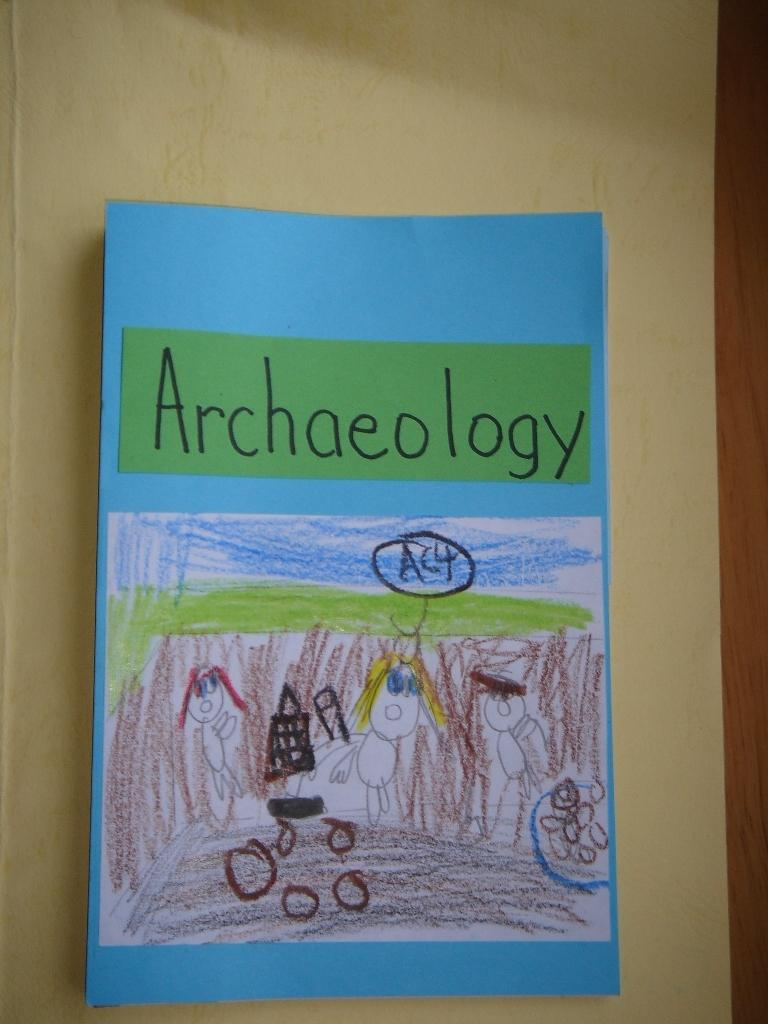Provide a one-sentence caption for the provided image. A child has drawn a picture of an Archaeology scene. 